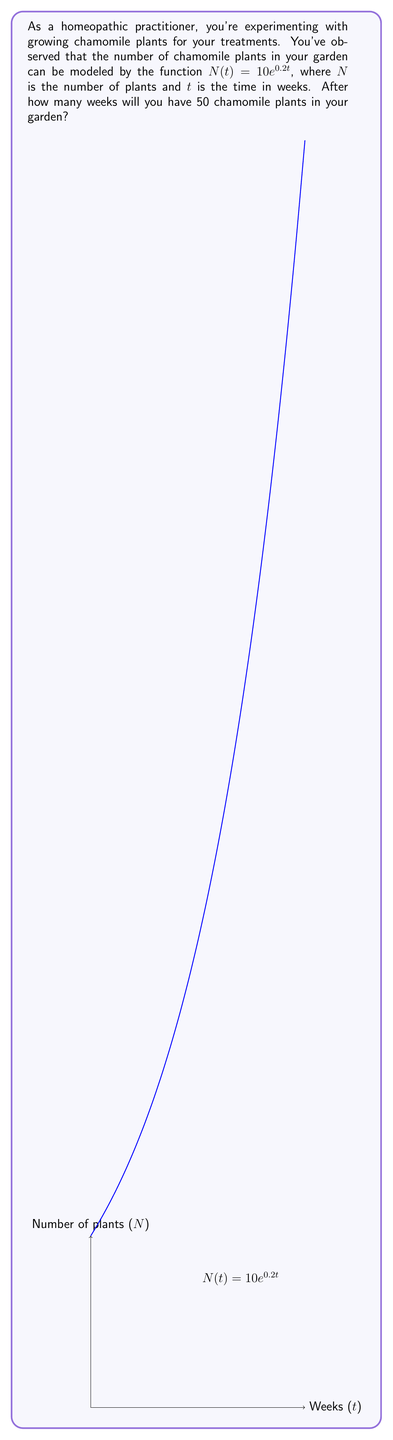Could you help me with this problem? Let's approach this step-by-step:

1) We're given the exponential growth function: $N(t) = 10e^{0.2t}$

2) We want to find $t$ when $N(t) = 50$. So, let's set up the equation:
   
   $50 = 10e^{0.2t}$

3) Divide both sides by 10:
   
   $5 = e^{0.2t}$

4) Take the natural logarithm of both sides:
   
   $\ln(5) = \ln(e^{0.2t})$

5) Using the property of logarithms, $\ln(e^x) = x$:
   
   $\ln(5) = 0.2t$

6) Solve for $t$:
   
   $t = \frac{\ln(5)}{0.2}$

7) Calculate the result:
   
   $t = \frac{\ln(5)}{0.2} \approx 8.047$ weeks

8) Since we can't have a fractional week in this context, we round up to the nearest whole week.
Answer: 9 weeks 